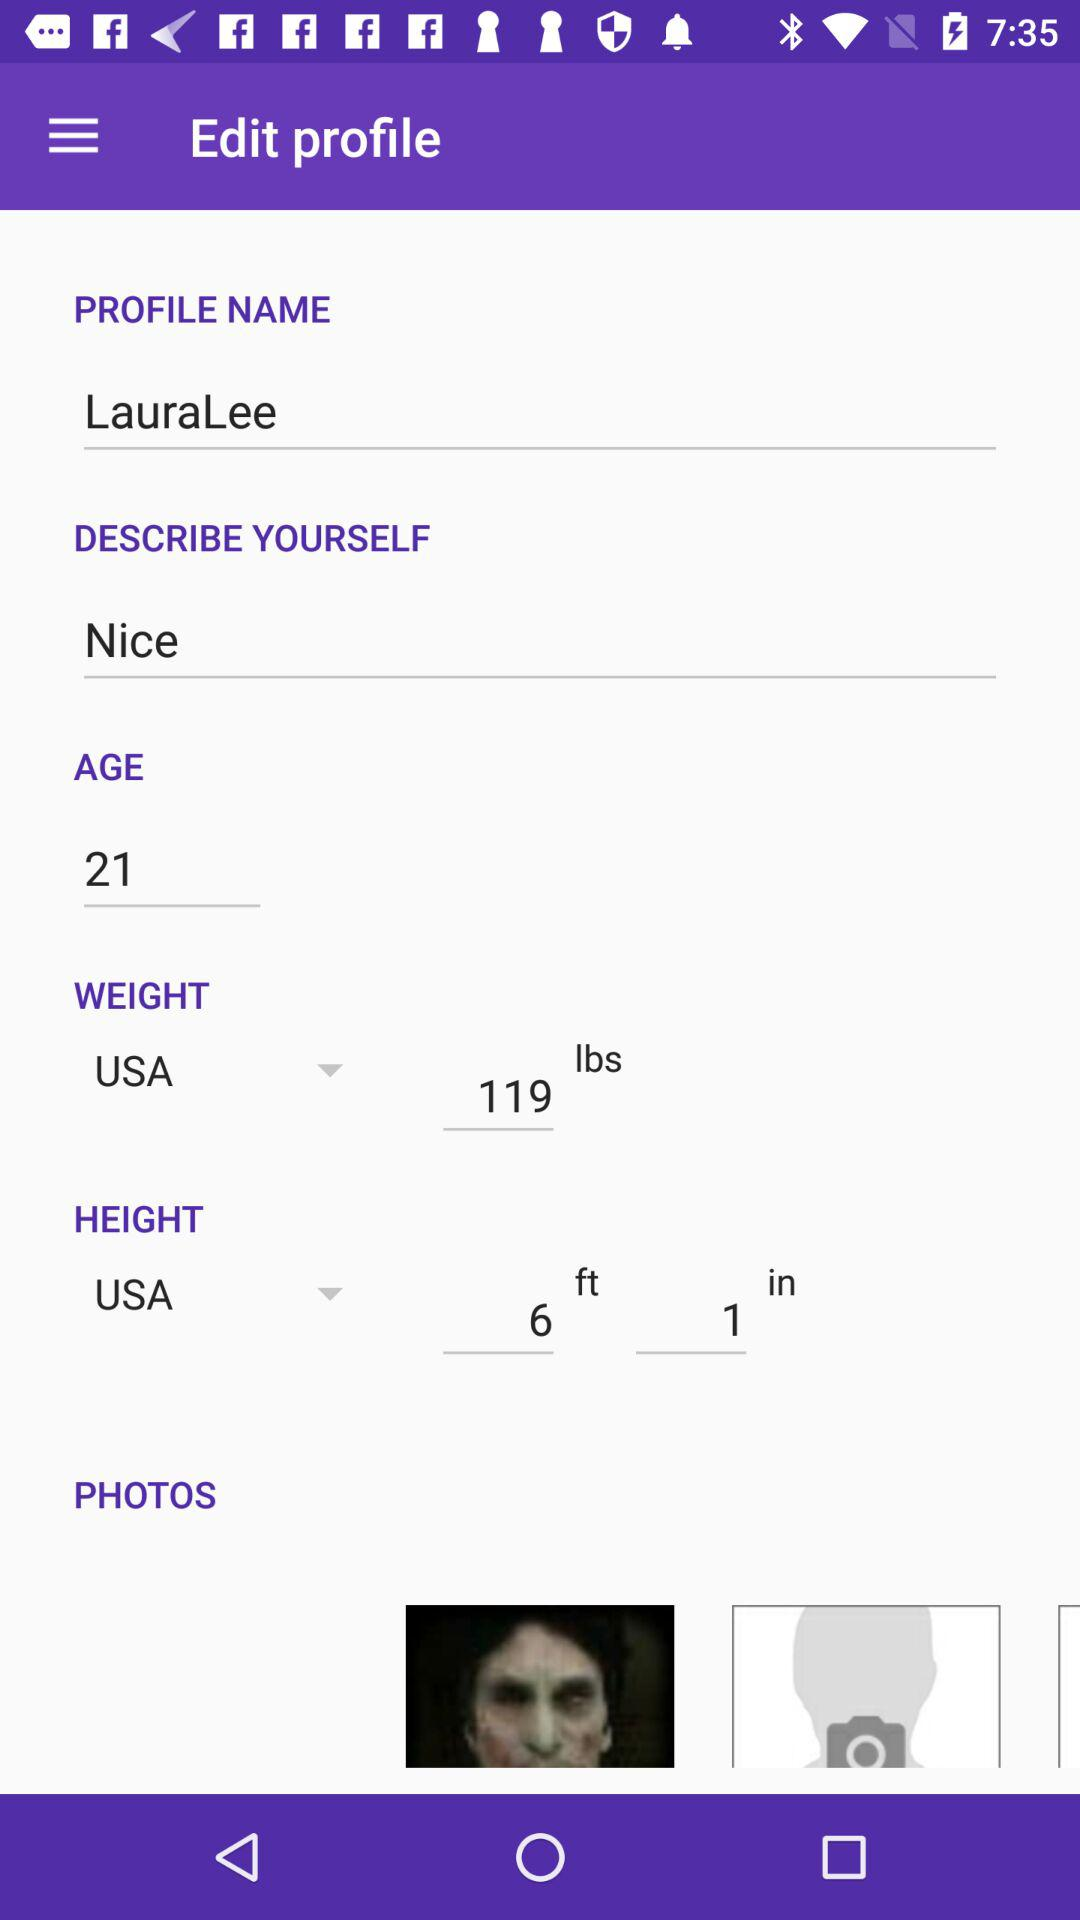What is the given weight? The given weight is 119 lbs. 